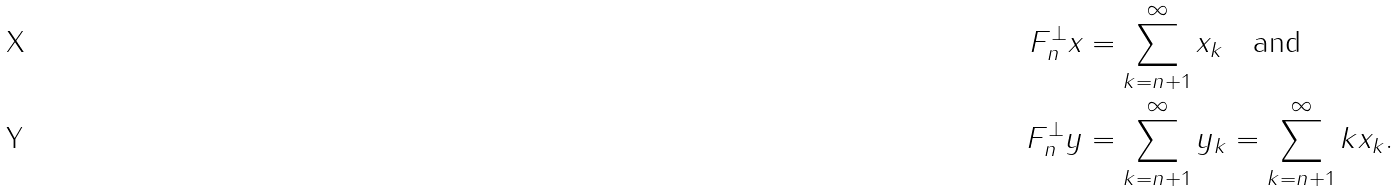<formula> <loc_0><loc_0><loc_500><loc_500>F _ { n } ^ { \perp } x & = \sum _ { k = n + 1 } ^ { \infty } x _ { k } \quad \text {and} \\ F _ { n } ^ { \perp } y & = \sum _ { k = n + 1 } ^ { \infty } y _ { k } = \sum _ { k = n + 1 } ^ { \infty } k x _ { k } .</formula> 